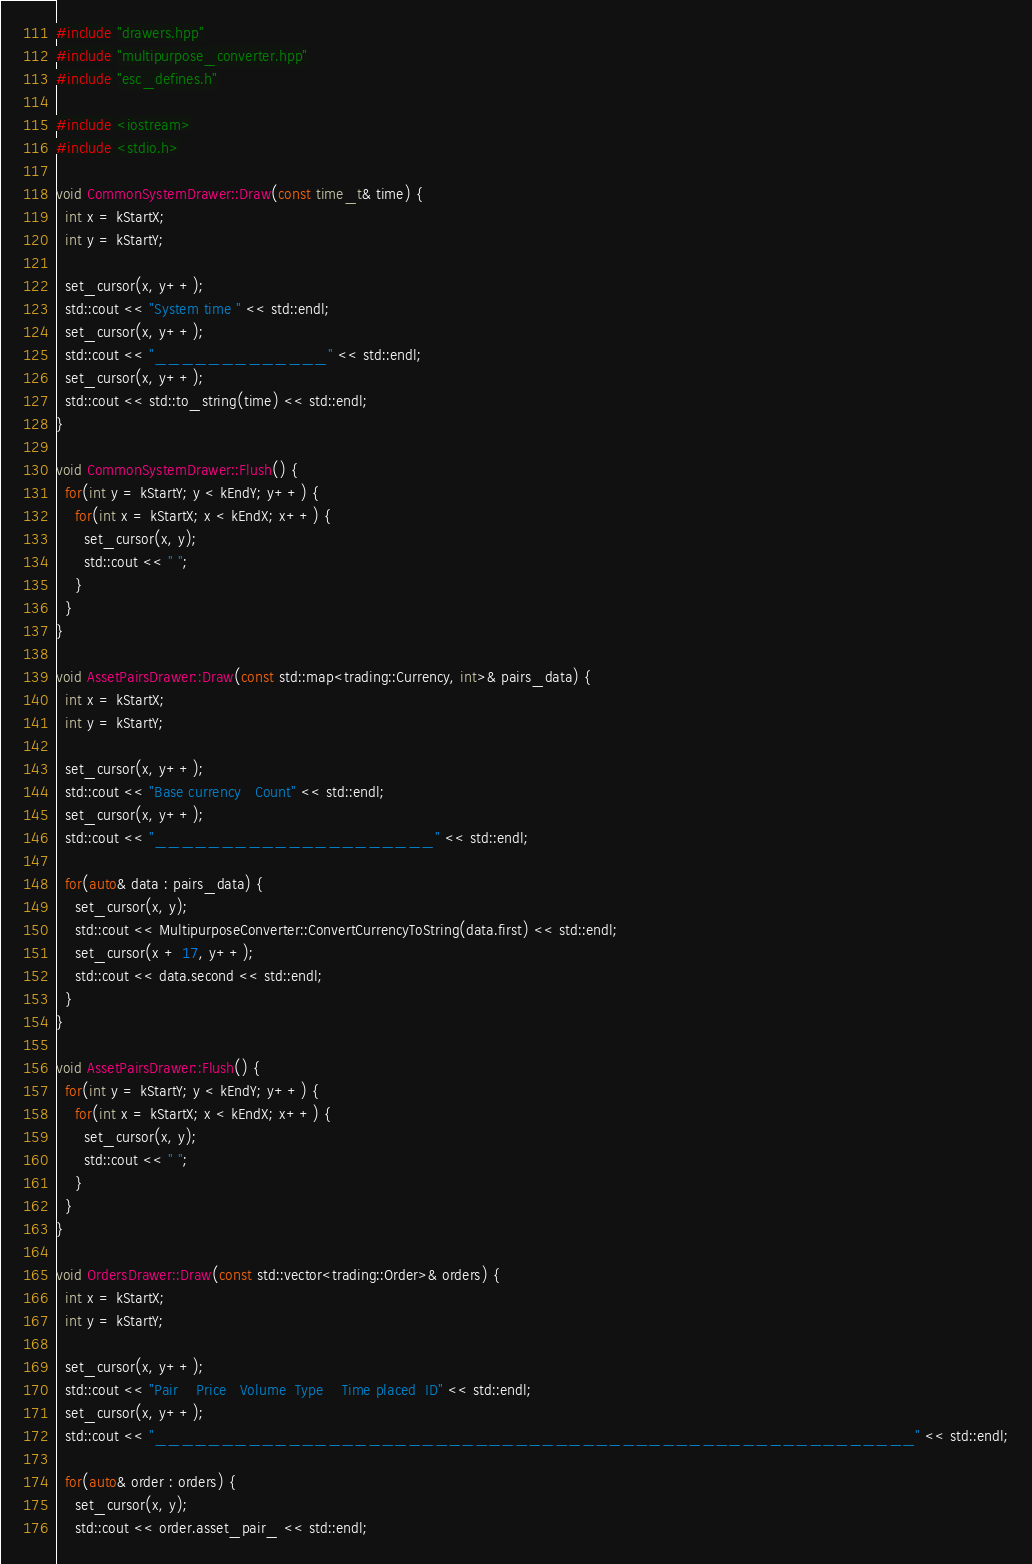<code> <loc_0><loc_0><loc_500><loc_500><_C++_>#include "drawers.hpp"
#include "multipurpose_converter.hpp"
#include "esc_defines.h"

#include <iostream>
#include <stdio.h>

void CommonSystemDrawer::Draw(const time_t& time) {
  int x = kStartX;
  int y = kStartY;

  set_cursor(x, y++);
  std::cout << "System time " << std::endl;
  set_cursor(x, y++);
  std::cout << "_____________" << std::endl;
  set_cursor(x, y++);
  std::cout << std::to_string(time) << std::endl;
}

void CommonSystemDrawer::Flush() {
  for(int y = kStartY; y < kEndY; y++) {
    for(int x = kStartX; x < kEndX; x++) {
      set_cursor(x, y);
      std::cout << " ";
    }
  }
}

void AssetPairsDrawer::Draw(const std::map<trading::Currency, int>& pairs_data) {
  int x = kStartX;
  int y = kStartY;

  set_cursor(x, y++);
  std::cout << "Base currency   Count" << std::endl;
  set_cursor(x, y++);
  std::cout << "_____________________" << std::endl;

  for(auto& data : pairs_data) {
    set_cursor(x, y);
    std::cout << MultipurposeConverter::ConvertCurrencyToString(data.first) << std::endl;
    set_cursor(x + 17, y++);
    std::cout << data.second << std::endl;
  }
}

void AssetPairsDrawer::Flush() {
  for(int y = kStartY; y < kEndY; y++) {
    for(int x = kStartX; x < kEndX; x++) {
      set_cursor(x, y);
      std::cout << " ";
    }
  }
}

void OrdersDrawer::Draw(const std::vector<trading::Order>& orders) {
  int x = kStartX;
  int y = kStartY;

  set_cursor(x, y++);
  std::cout << "Pair    Price   Volume  Type    Time placed  ID" << std::endl;
  set_cursor(x, y++);
  std::cout << "_________________________________________________________" << std::endl;

  for(auto& order : orders) {
    set_cursor(x, y);
    std::cout << order.asset_pair_ << std::endl;</code> 